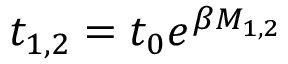<formula> <loc_0><loc_0><loc_500><loc_500>t _ { 1 , 2 } = t _ { 0 } e ^ { \beta M _ { 1 , 2 } }</formula> 